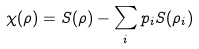Convert formula to latex. <formula><loc_0><loc_0><loc_500><loc_500>\chi ( \rho ) = S ( \rho ) - \sum _ { i } p _ { i } S ( \rho _ { i } )</formula> 